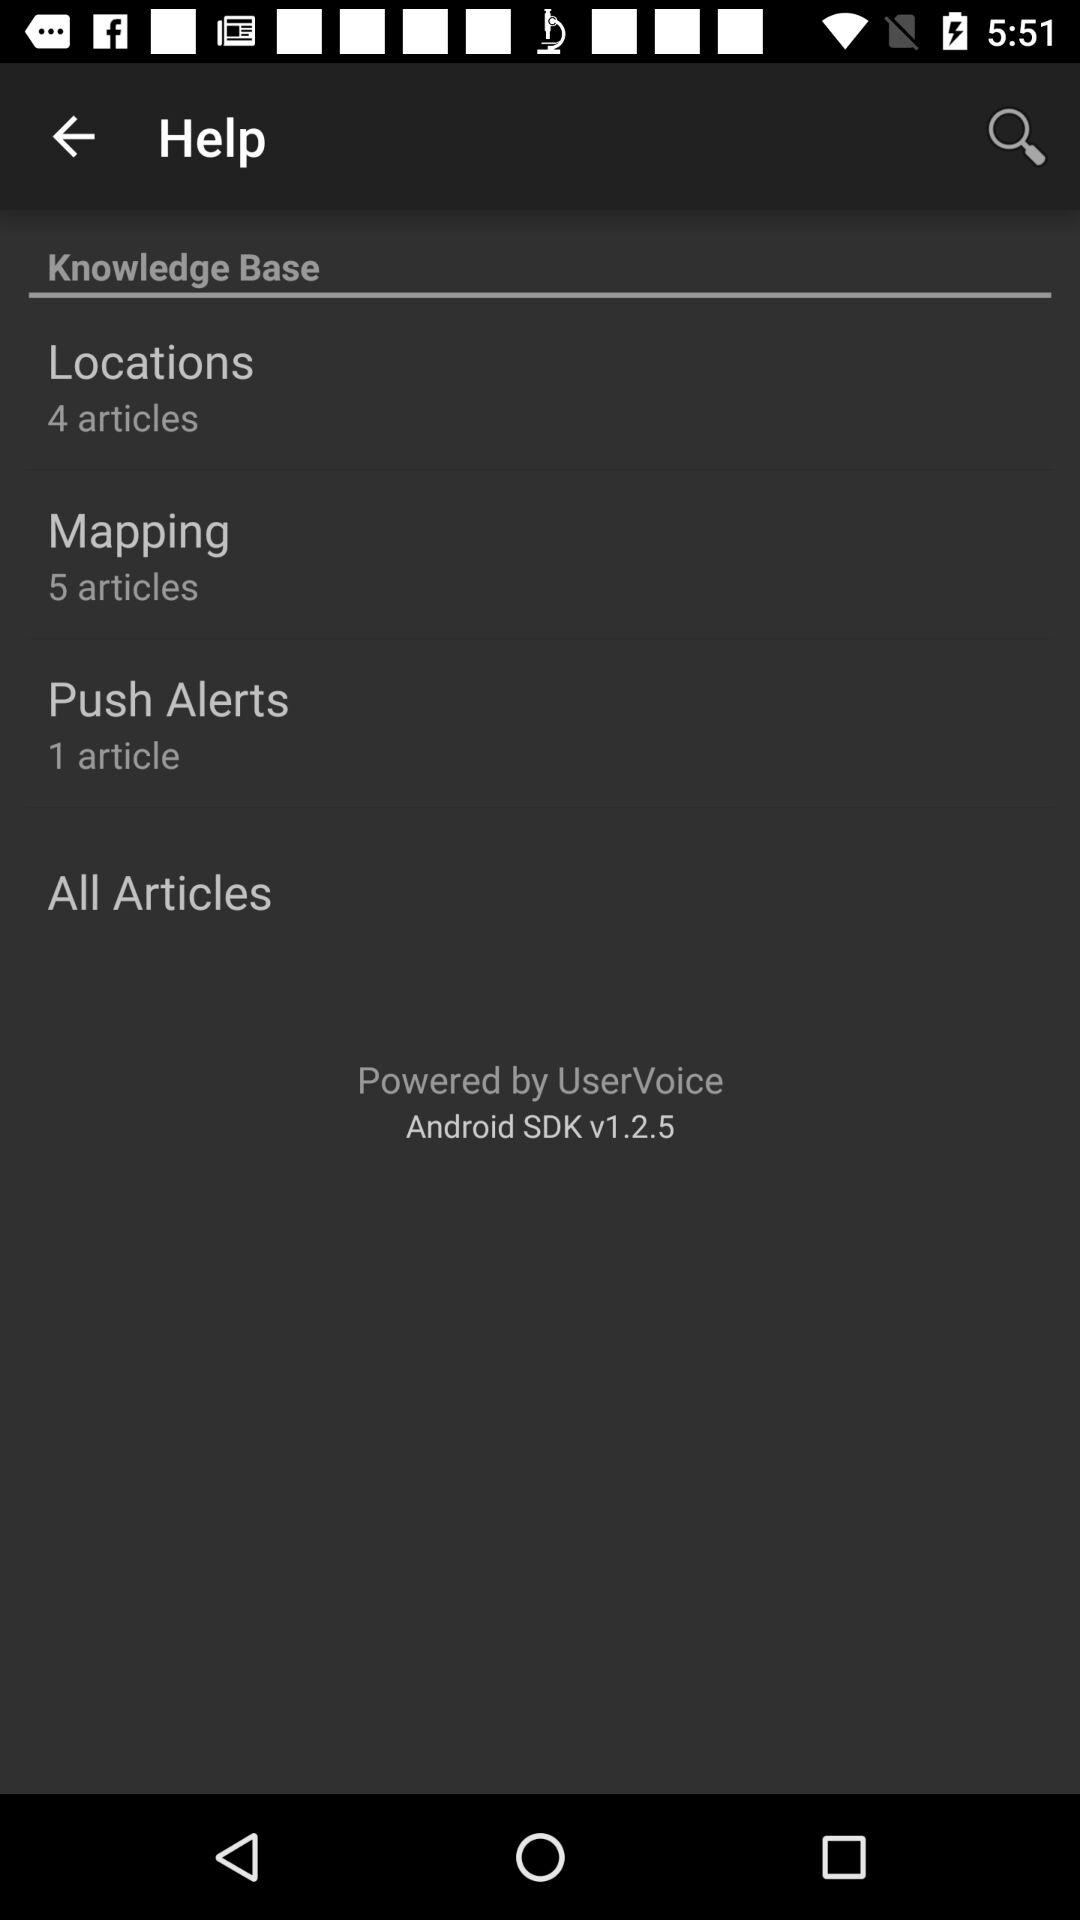How many "All Articles" are there?
When the provided information is insufficient, respond with <no answer>. <no answer> 